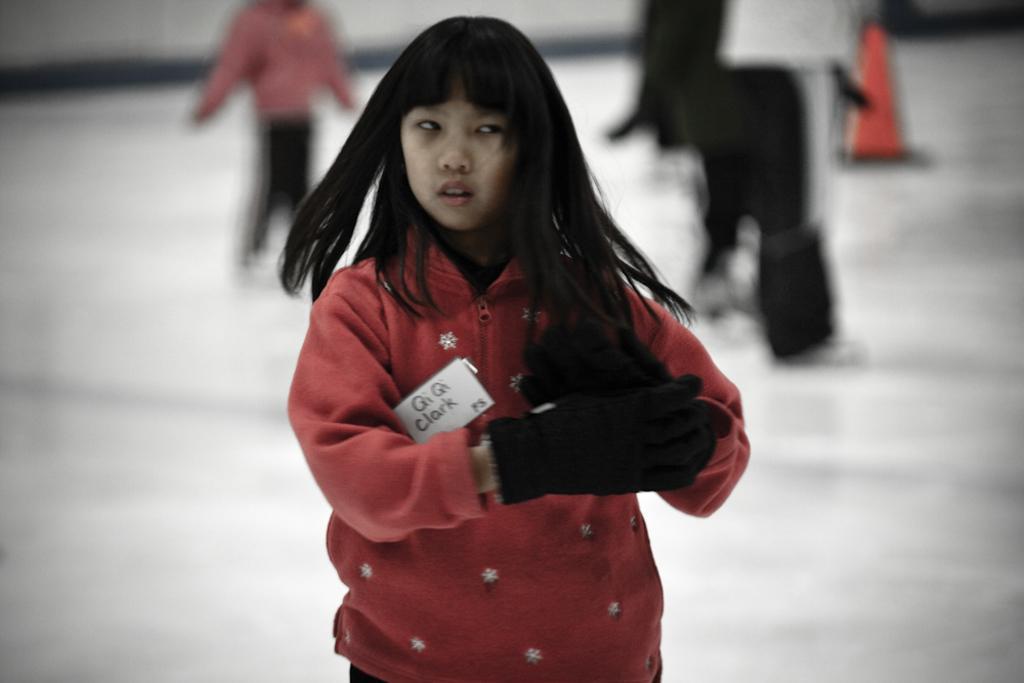Can you describe this image briefly? In this image we can see a girl. She is wearing red jacket and black gloves. We can see people are standing on the white color surface in the background. 